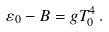<formula> <loc_0><loc_0><loc_500><loc_500>\varepsilon _ { 0 } - B = g T ^ { 4 } _ { 0 } \, .</formula> 